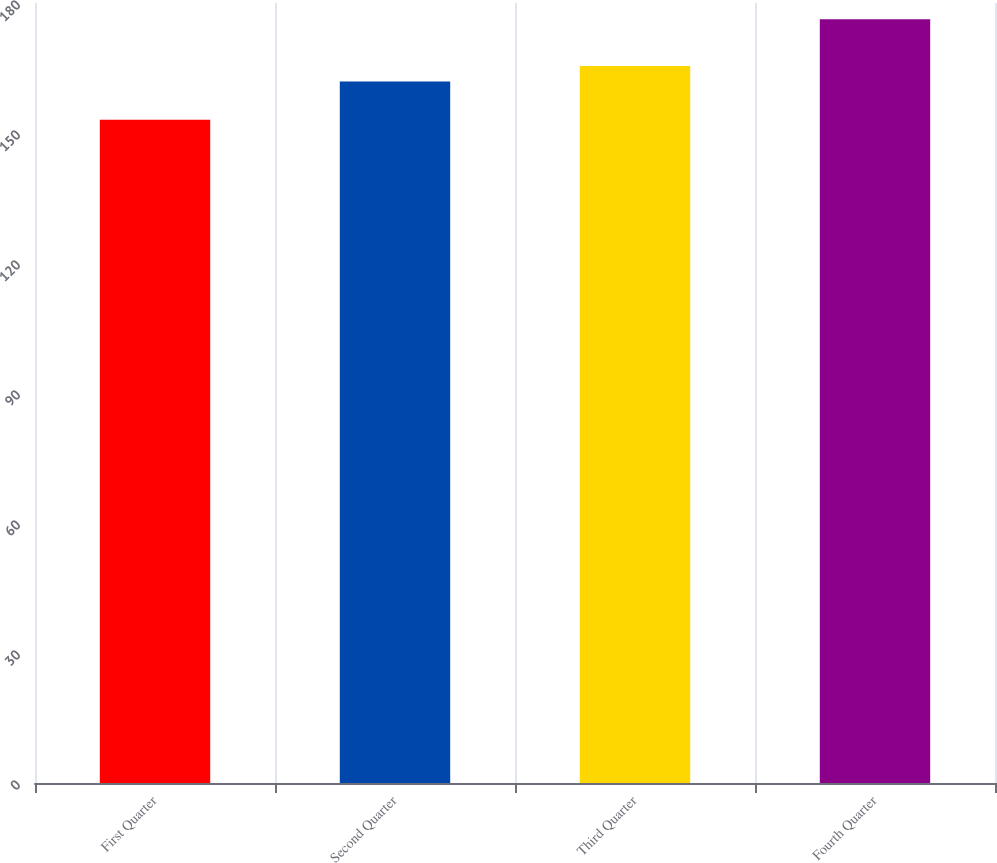Convert chart to OTSL. <chart><loc_0><loc_0><loc_500><loc_500><bar_chart><fcel>First Quarter<fcel>Second Quarter<fcel>Third Quarter<fcel>Fourth Quarter<nl><fcel>153.05<fcel>161.87<fcel>165.46<fcel>176.27<nl></chart> 